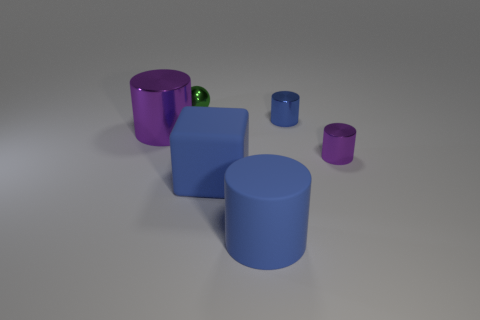Are there any other things that have the same shape as the tiny green metal thing?
Make the answer very short. No. How many metal things are either tiny brown cylinders or large blue objects?
Your answer should be very brief. 0. Do the shiny thing that is in front of the large purple shiny thing and the small blue object have the same shape?
Keep it short and to the point. Yes. Are there more tiny green spheres that are on the right side of the tiny green shiny ball than big purple metal objects?
Keep it short and to the point. No. How many metal things are to the left of the small blue metallic object and in front of the small green object?
Your answer should be compact. 1. The sphere that is behind the purple metal thing on the left side of the small green object is what color?
Provide a succinct answer. Green. How many objects are the same color as the big block?
Offer a terse response. 2. Does the tiny ball have the same color as the small object that is in front of the big purple metallic thing?
Provide a short and direct response. No. Are there fewer small green balls than purple shiny things?
Keep it short and to the point. Yes. Are there more small purple things in front of the tiny shiny sphere than cylinders that are on the right side of the small purple cylinder?
Keep it short and to the point. Yes. 